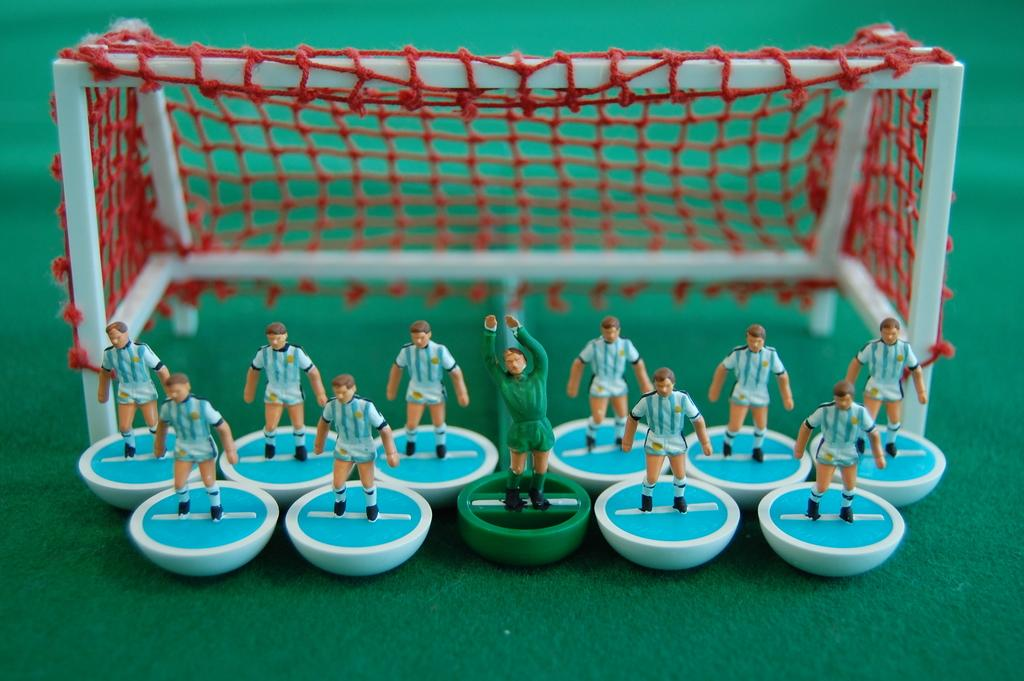What type of miniatures are present in the image? There are miniatures of football players in the image. What is the main feature of the image related to football? There is a goal post in the image. What is the level of pollution in the aftermath of the football game in the image? There is no football game or pollution present in the image; it only features miniature football players and a goal post. 